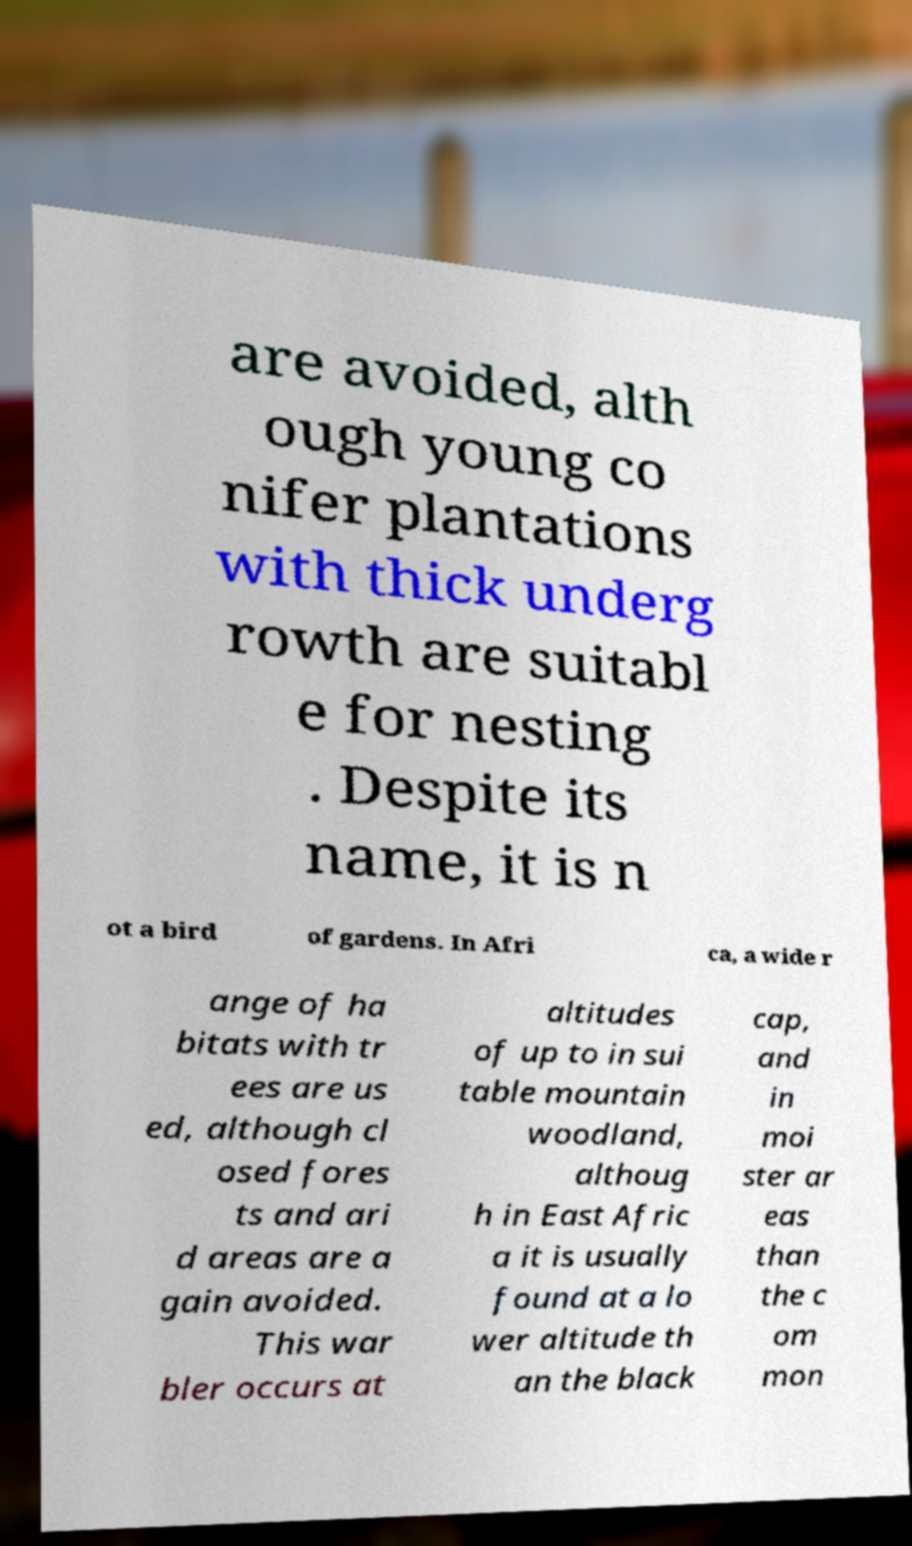For documentation purposes, I need the text within this image transcribed. Could you provide that? are avoided, alth ough young co nifer plantations with thick underg rowth are suitabl e for nesting . Despite its name, it is n ot a bird of gardens. In Afri ca, a wide r ange of ha bitats with tr ees are us ed, although cl osed fores ts and ari d areas are a gain avoided. This war bler occurs at altitudes of up to in sui table mountain woodland, althoug h in East Afric a it is usually found at a lo wer altitude th an the black cap, and in moi ster ar eas than the c om mon 